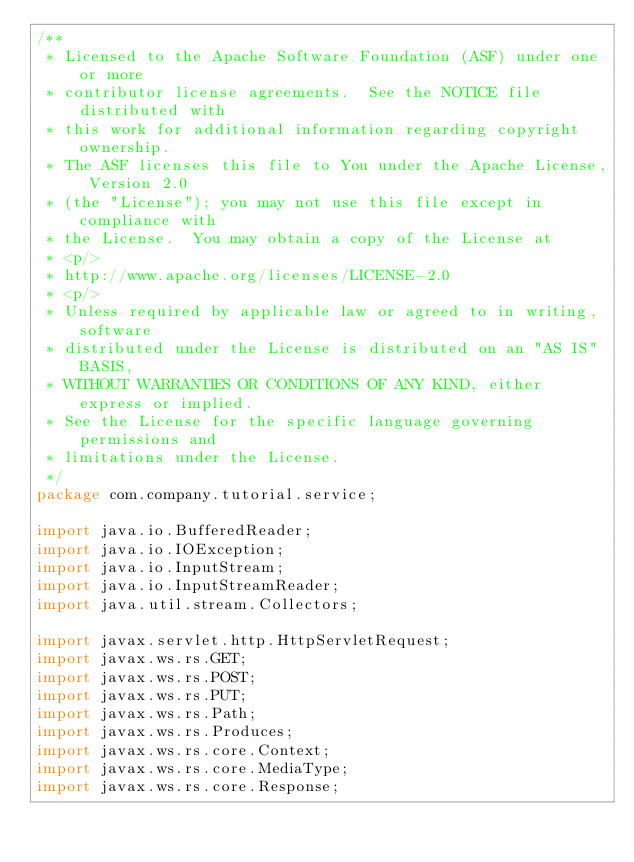<code> <loc_0><loc_0><loc_500><loc_500><_Java_>/**
 * Licensed to the Apache Software Foundation (ASF) under one or more
 * contributor license agreements.  See the NOTICE file distributed with
 * this work for additional information regarding copyright ownership.
 * The ASF licenses this file to You under the Apache License, Version 2.0
 * (the "License"); you may not use this file except in compliance with
 * the License.  You may obtain a copy of the License at
 * <p/>
 * http://www.apache.org/licenses/LICENSE-2.0
 * <p/>
 * Unless required by applicable law or agreed to in writing, software
 * distributed under the License is distributed on an "AS IS" BASIS,
 * WITHOUT WARRANTIES OR CONDITIONS OF ANY KIND, either express or implied.
 * See the License for the specific language governing permissions and
 * limitations under the License.
 */
package com.company.tutorial.service;

import java.io.BufferedReader;
import java.io.IOException;
import java.io.InputStream;
import java.io.InputStreamReader;
import java.util.stream.Collectors;

import javax.servlet.http.HttpServletRequest;
import javax.ws.rs.GET;
import javax.ws.rs.POST;
import javax.ws.rs.PUT;
import javax.ws.rs.Path;
import javax.ws.rs.Produces;
import javax.ws.rs.core.Context;
import javax.ws.rs.core.MediaType;
import javax.ws.rs.core.Response;
</code> 